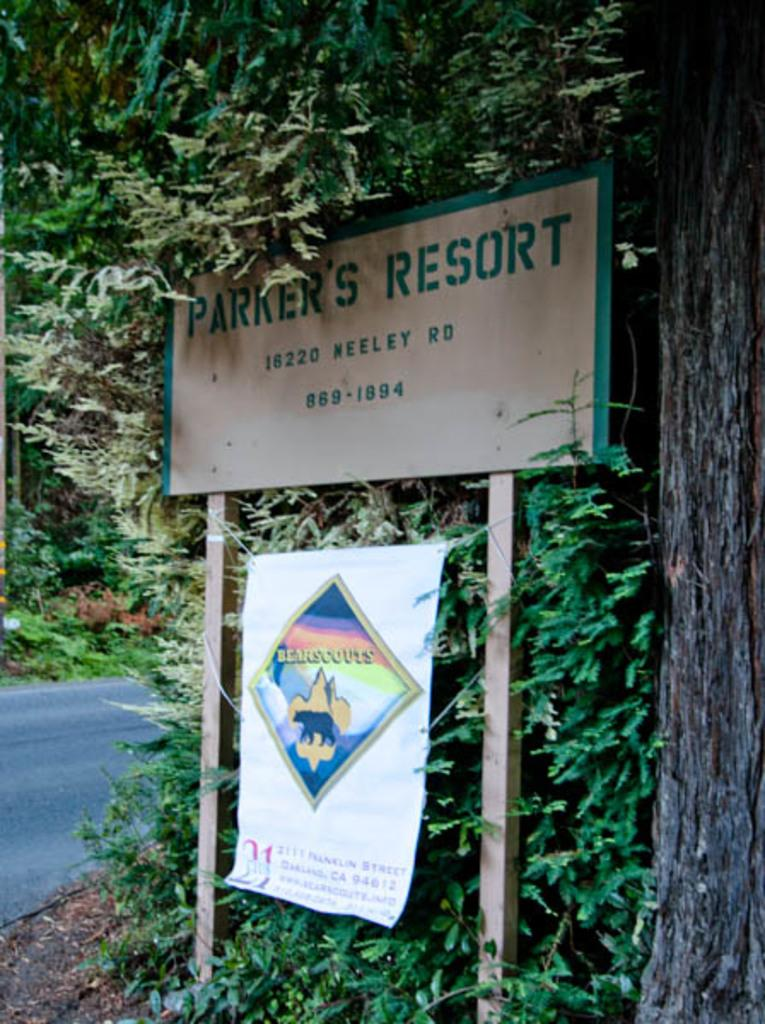What is present in the image that is used for displaying information or messages? There is a board and a banner in the image that are used for displaying information or messages. How are the board and banner positioned in the image? The board and banner are attached to poles in the image. What can be seen behind the board in the image? Leaves are visible behind the board in the image. What is visible in the background of the image? There is a road and plants in the background of the image. What type of fruit is being sold in the office in the image? There is no office or fruit being sold in the image; it features a board and banner with leaves and a road in the background. 